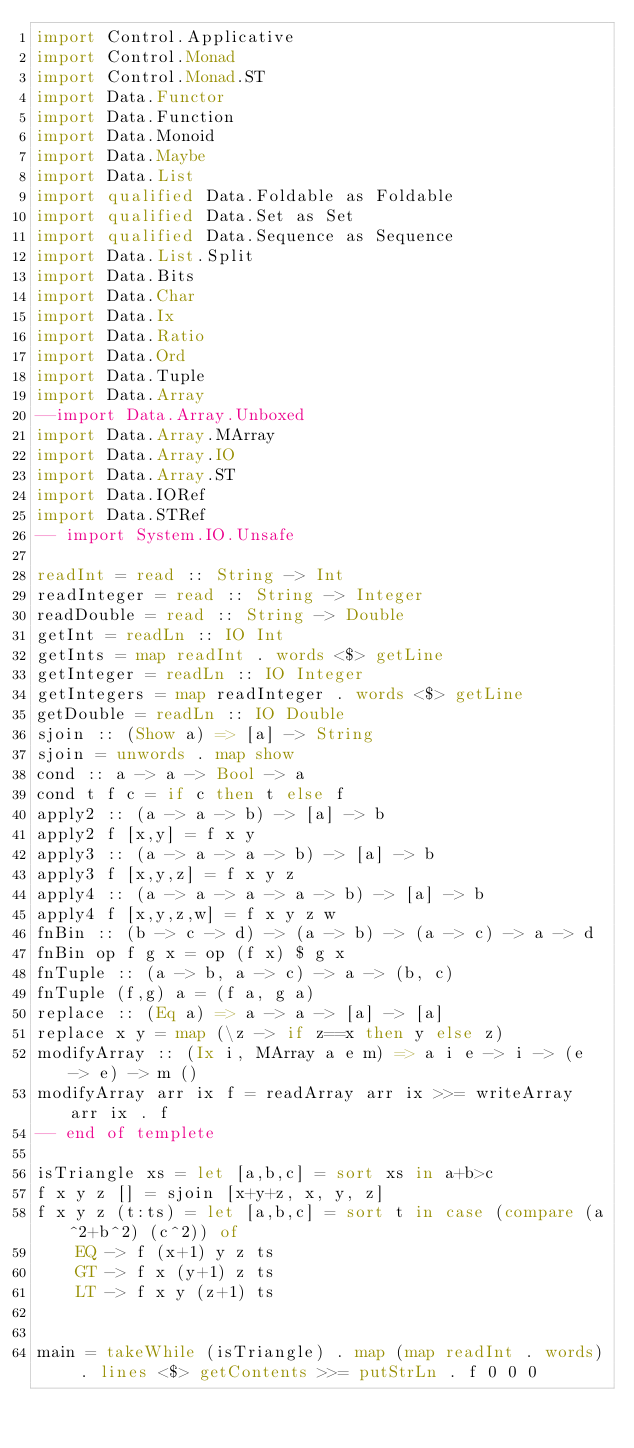Convert code to text. <code><loc_0><loc_0><loc_500><loc_500><_Haskell_>import Control.Applicative
import Control.Monad
import Control.Monad.ST
import Data.Functor
import Data.Function
import Data.Monoid
import Data.Maybe
import Data.List
import qualified Data.Foldable as Foldable
import qualified Data.Set as Set
import qualified Data.Sequence as Sequence
import Data.List.Split
import Data.Bits
import Data.Char
import Data.Ix
import Data.Ratio
import Data.Ord
import Data.Tuple
import Data.Array
--import Data.Array.Unboxed
import Data.Array.MArray
import Data.Array.IO
import Data.Array.ST
import Data.IORef
import Data.STRef
-- import System.IO.Unsafe
 
readInt = read :: String -> Int
readInteger = read :: String -> Integer
readDouble = read :: String -> Double
getInt = readLn :: IO Int
getInts = map readInt . words <$> getLine
getInteger = readLn :: IO Integer
getIntegers = map readInteger . words <$> getLine
getDouble = readLn :: IO Double
sjoin :: (Show a) => [a] -> String
sjoin = unwords . map show
cond :: a -> a -> Bool -> a
cond t f c = if c then t else f
apply2 :: (a -> a -> b) -> [a] -> b
apply2 f [x,y] = f x y
apply3 :: (a -> a -> a -> b) -> [a] -> b
apply3 f [x,y,z] = f x y z
apply4 :: (a -> a -> a -> a -> b) -> [a] -> b
apply4 f [x,y,z,w] = f x y z w
fnBin :: (b -> c -> d) -> (a -> b) -> (a -> c) -> a -> d
fnBin op f g x = op (f x) $ g x
fnTuple :: (a -> b, a -> c) -> a -> (b, c)
fnTuple (f,g) a = (f a, g a)
replace :: (Eq a) => a -> a -> [a] -> [a]
replace x y = map (\z -> if z==x then y else z)
modifyArray :: (Ix i, MArray a e m) => a i e -> i -> (e -> e) -> m ()
modifyArray arr ix f = readArray arr ix >>= writeArray arr ix . f
-- end of templete

isTriangle xs = let [a,b,c] = sort xs in a+b>c
f x y z [] = sjoin [x+y+z, x, y, z]
f x y z (t:ts) = let [a,b,c] = sort t in case (compare (a^2+b^2) (c^2)) of
    EQ -> f (x+1) y z ts
    GT -> f x (y+1) z ts
    LT -> f x y (z+1) ts


main = takeWhile (isTriangle) . map (map readInt . words) . lines <$> getContents >>= putStrLn . f 0 0 0</code> 